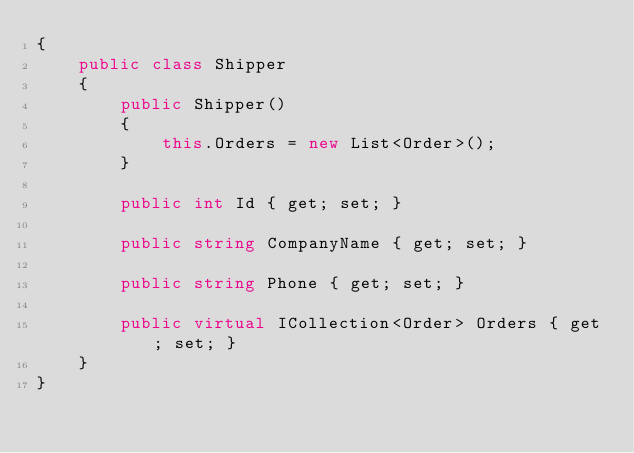<code> <loc_0><loc_0><loc_500><loc_500><_C#_>{
    public class Shipper
    {
        public Shipper()
        {
            this.Orders = new List<Order>();
        }

        public int Id { get; set; }

        public string CompanyName { get; set; }

        public string Phone { get; set; }

        public virtual ICollection<Order> Orders { get; set; }
    }
}
</code> 